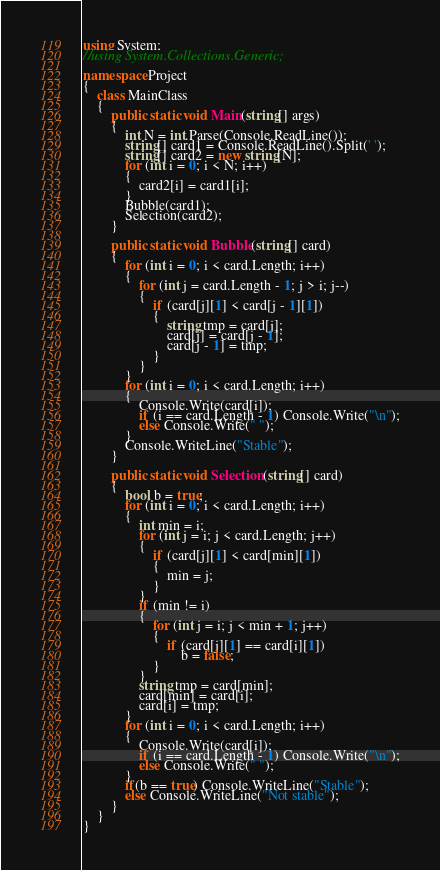Convert code to text. <code><loc_0><loc_0><loc_500><loc_500><_C#_>using System;
//using System.Collections.Generic;

namespace Project
{
	class MainClass
	{
		public static void Main(string[] args)
		{
			int N = int.Parse(Console.ReadLine());
			string[] card1 = Console.ReadLine().Split(' ');
			string[] card2 = new string[N];
			for (int i = 0; i < N; i++)
			{
				card2[i] = card1[i];
			}
			Bubble(card1);
			Selection(card2);
		}

		public static void Bubble(string[] card)
		{
			for (int i = 0; i < card.Length; i++)
			{
				for (int j = card.Length - 1; j > i; j--)
				{
					if (card[j][1] < card[j - 1][1])
					{
						string tmp = card[j];
						card[j] = card[j - 1];
						card[j - 1] = tmp;
					}
				}
			}
			for (int i = 0; i < card.Length; i++)
			{
				Console.Write(card[i]);
				if (i == card.Length - 1) Console.Write("\n");
				else Console.Write(" ");
			}
			Console.WriteLine("Stable");
		}

		public static void Selection(string[] card)
		{
			bool b = true;
			for (int i = 0; i < card.Length; i++)
			{
				int min = i;
				for (int j = i; j < card.Length; j++)
				{
					if (card[j][1] < card[min][1])
					{
						min = j;
					}
				}
				if (min != i)
				{
					for (int j = i; j < min + 1; j++)
					{
						if (card[j][1] == card[i][1])
							b = false;
					}
				}
				string tmp = card[min];
				card[min] = card[i];
				card[i] = tmp;
			}
			for (int i = 0; i < card.Length; i++)
			{
				Console.Write(card[i]);
				if (i == card.Length - 1) Console.Write("\n");
				else Console.Write(" ");
			}
			if(b == true) Console.WriteLine("Stable");
			else Console.WriteLine("Not stable");
		}
	}
}</code> 